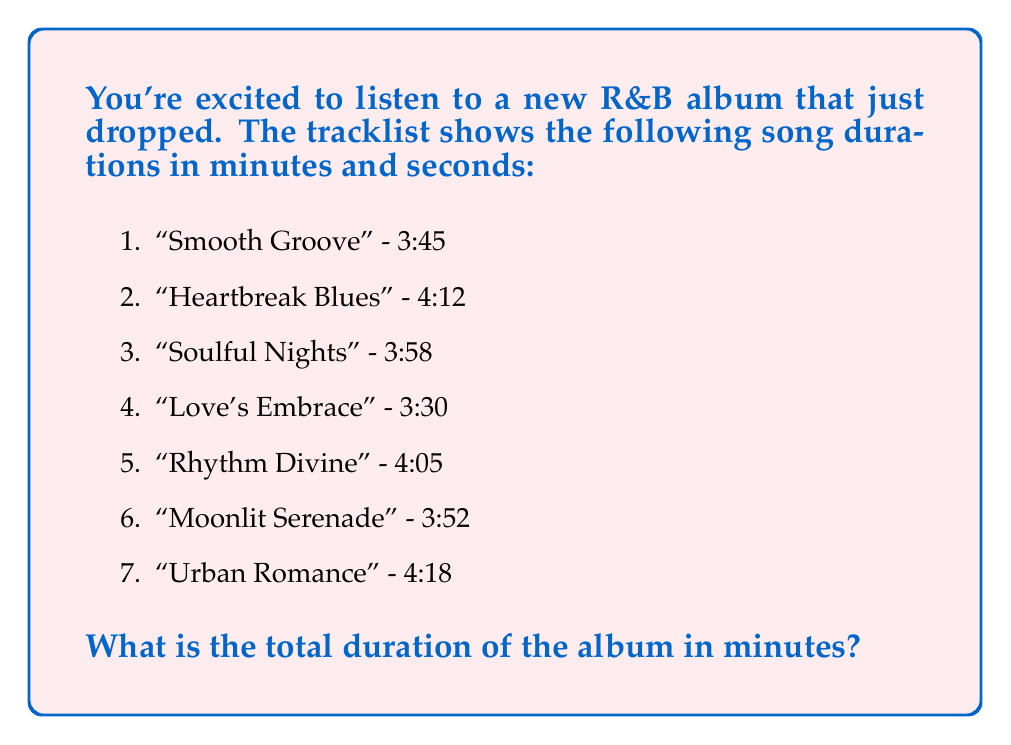Help me with this question. To find the total duration of the album, we need to:
1. Convert each song's duration to seconds
2. Add up all the durations in seconds
3. Convert the total back to minutes

Let's go through this step-by-step:

1. Converting each song to seconds:
   * "Smooth Groove": $3 \times 60 + 45 = 225$ seconds
   * "Heartbreak Blues": $4 \times 60 + 12 = 252$ seconds
   * "Soulful Nights": $3 \times 60 + 58 = 238$ seconds
   * "Love's Embrace": $3 \times 60 + 30 = 210$ seconds
   * "Rhythm Divine": $4 \times 60 + 5 = 245$ seconds
   * "Moonlit Serenade": $3 \times 60 + 52 = 232$ seconds
   * "Urban Romance": $4 \times 60 + 18 = 258$ seconds

2. Adding up all durations:
   $$225 + 252 + 238 + 210 + 245 + 232 + 258 = 1660$$ seconds

3. Converting back to minutes:
   $$1660 \div 60 = 27.6666...$$ minutes

Therefore, the total duration of the album is approximately 27.67 minutes.
Answer: 27.67 minutes 